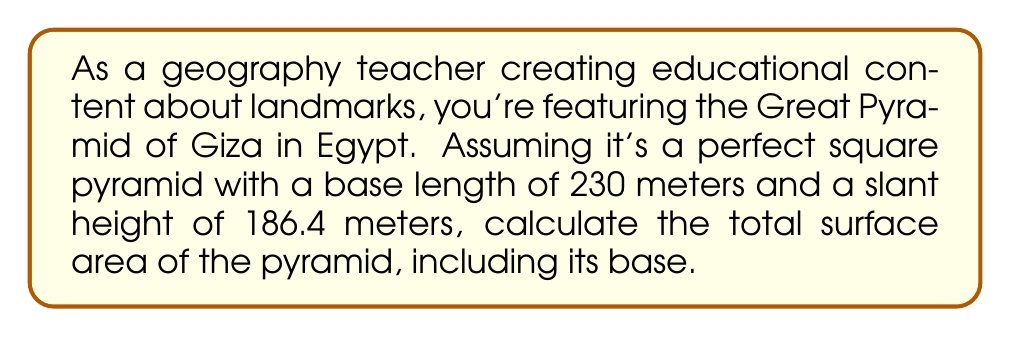Show me your answer to this math problem. Let's approach this step-by-step:

1) The surface area of a square pyramid consists of two parts:
   a) The area of the square base
   b) The area of the four triangular faces

2) For the square base:
   - Area of base = $s^2$, where $s$ is the side length
   - Area of base = $230^2 = 52,900$ m²

3) For each triangular face:
   - We need to find the base of the triangle (which is the side of the pyramid)
   - Area of triangle = $\frac{1}{2} \times base \times height$
   - Here, the height is the slant height of the pyramid

4) Area of one triangular face:
   $A_{face} = \frac{1}{2} \times 230 \times 186.4 = 21,436$ m²

5) There are four identical triangular faces, so:
   Total area of faces = $4 \times 21,436 = 85,744$ m²

6) Total surface area:
   $$A_{total} = A_{base} + A_{faces}$$
   $$A_{total} = 52,900 + 85,744 = 138,644 \text{ m²}$$

Therefore, the total surface area of the Great Pyramid is 138,644 square meters.
Answer: 138,644 m² 